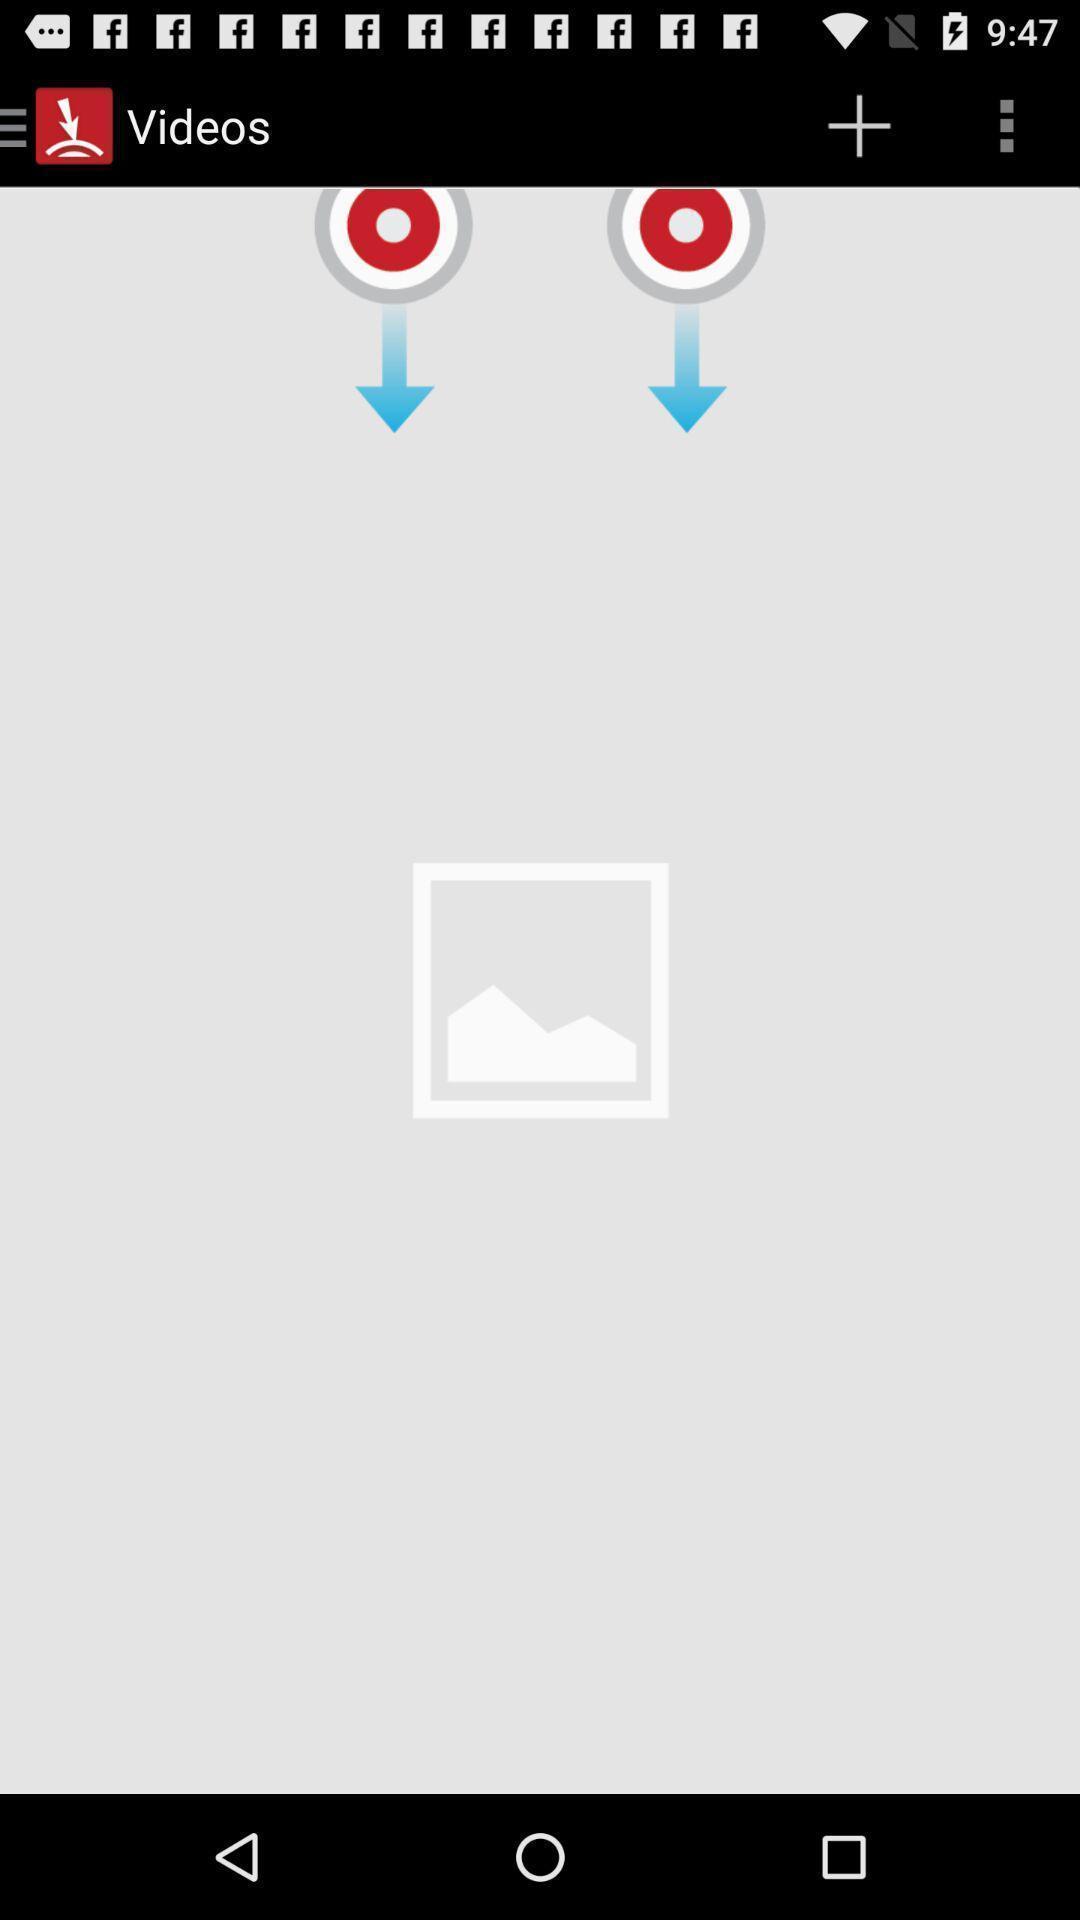Tell me about the visual elements in this screen capture. Screen showing no videos. 